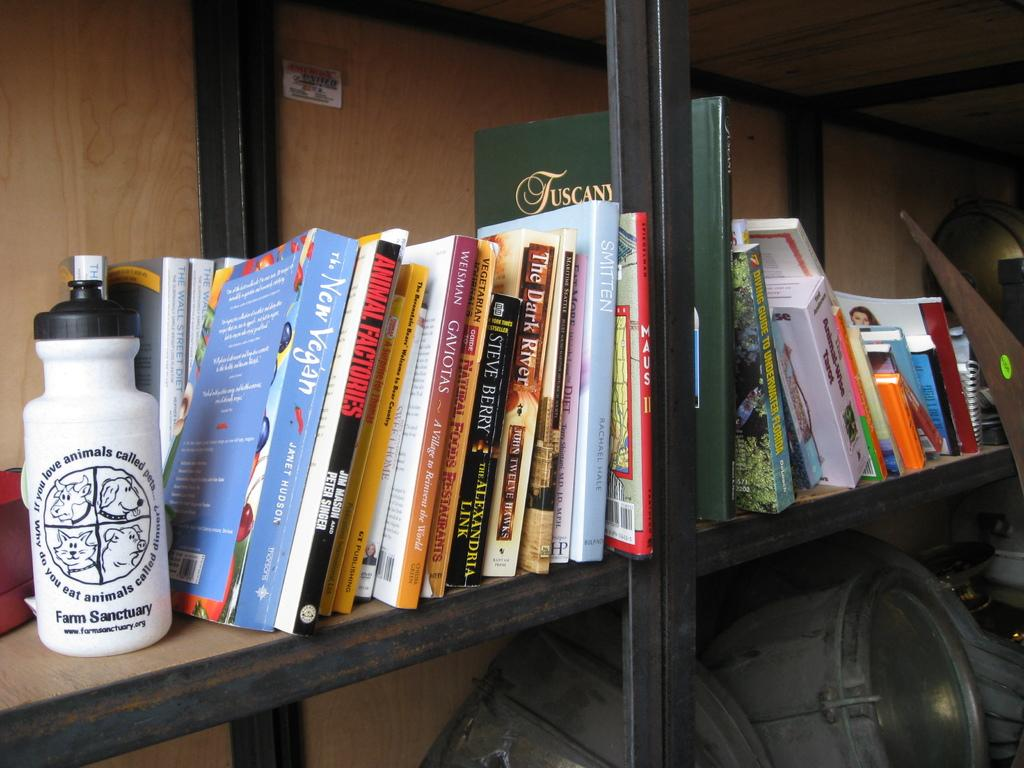Provide a one-sentence caption for the provided image. Several books standing on a bookshelf next to a Farm Sanctuary water bottle. 